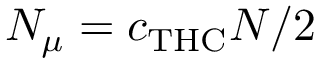Convert formula to latex. <formula><loc_0><loc_0><loc_500><loc_500>N _ { \mu } = c _ { T H C } N / 2</formula> 